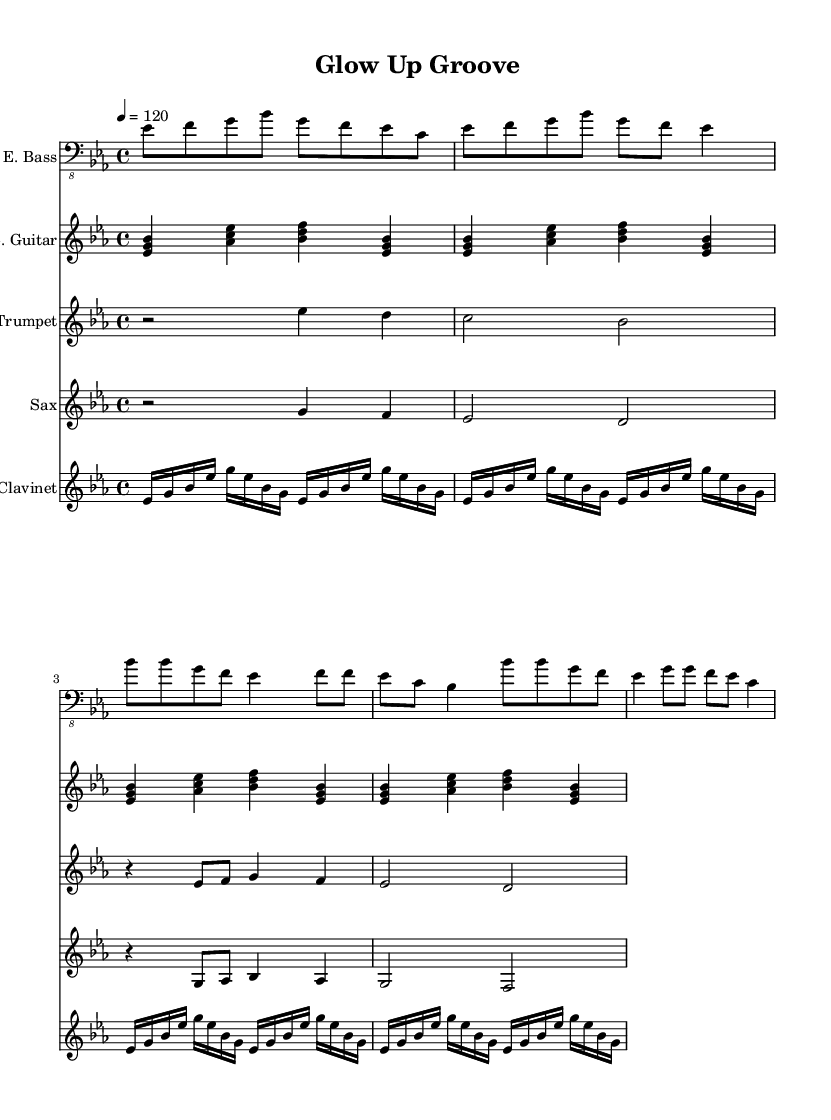What is the key signature of this music? The key signature is E flat major, which has three flats: B flat, E flat, and A flat. This can be determined by counting the flats at the beginning of the staff, indicating that the piece is in E flat major.
Answer: E flat major What is the time signature of this music? The time signature is 4/4, which is common in many musical genres including funk. This can be identified from the "4/4" notation at the beginning of the music sheet.
Answer: 4/4 What is the tempo marking for this piece? The tempo marking is 120 beats per minute. This is seen in the tempo indication at the beginning of the piece, which provides the speed at which the music should be played.
Answer: 120 How many instruments are featured in this score? There are five instruments featured in the score: Electric Bass, Electric Guitar, Trumpet, Sax, and Clavinet. Each instrument is indicated by a new staff in the score, showing the diverse sounds typical in funk music.
Answer: Five What is the main rhythmic structure used in the electric bass part? The main rhythmic structure consists of eighth notes, which create a lively and syncopated feel. By looking at the electric bass line, we can see the consistent use of eighth note rhythms throughout the piece, characteristic of funk.
Answer: Eighth notes What genre does this piece belong to? This piece belongs to the funk genre, characterized by its upbeat rhythm and strong basslines, as indicated by the musical elements and style presented throughout the score.
Answer: Funk What is the primary harmonic progression observed in the verse section? The primary harmonic progression revolves around the tonic (E flat) and dominant (B flat), creating a sense of resolution typical in funk music. By analyzing the chord changes in the verse, we can identify this structure prevails throughout the section.
Answer: Tonic and dominant 